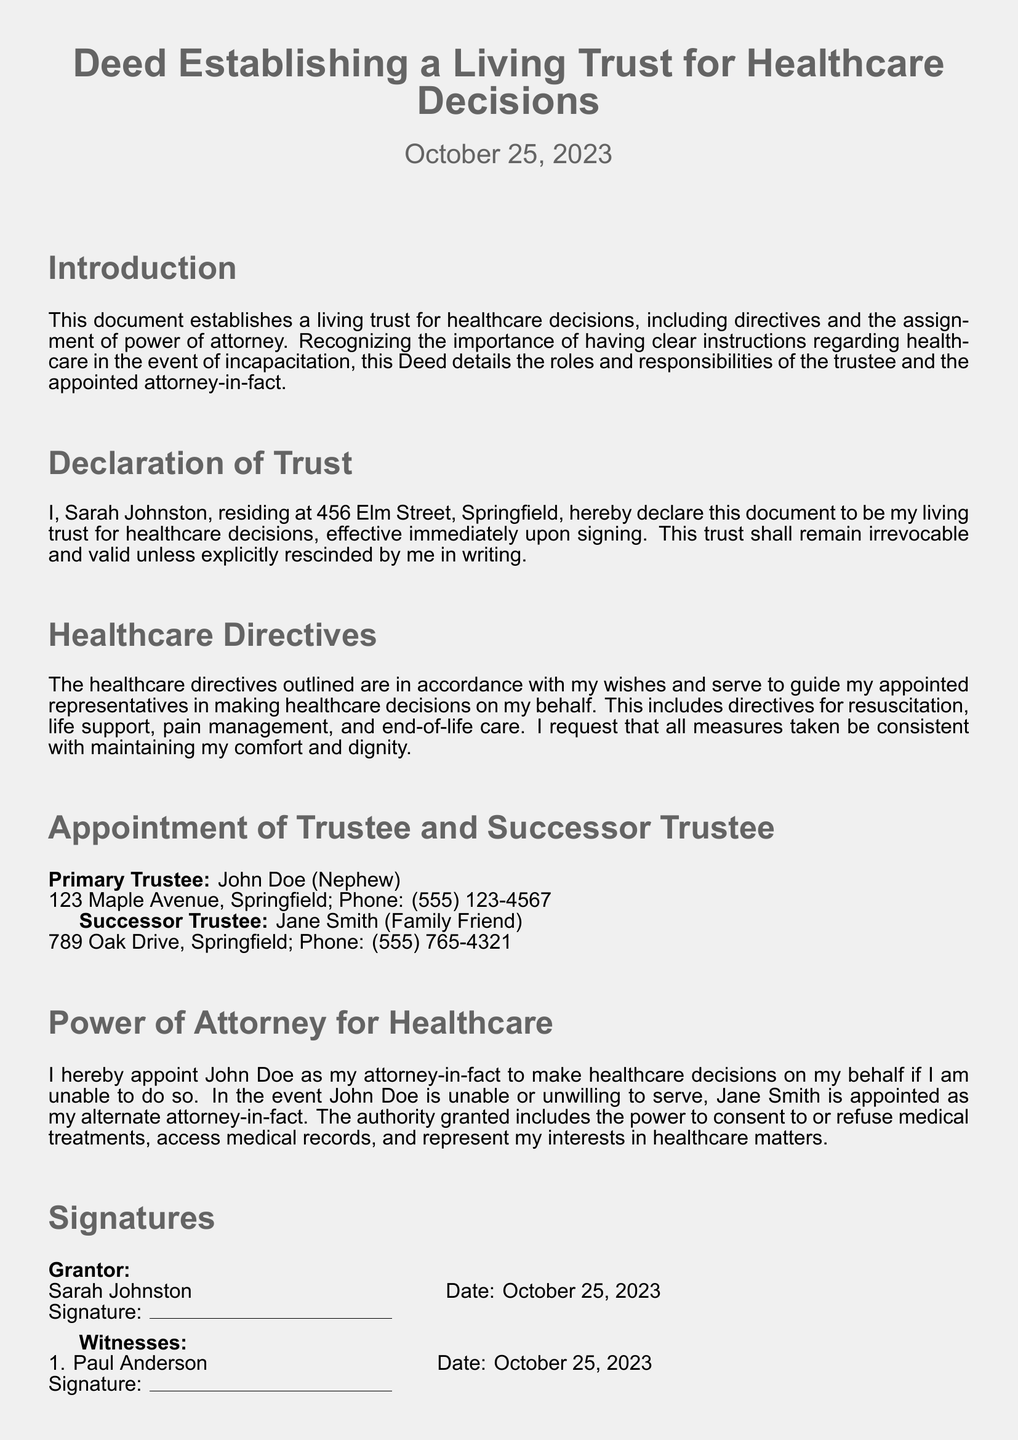What is the date of the document? The date of the document is mentioned at the top, indicating its creation date.
Answer: October 25, 2023 Who is the primary trustee? The primary trustee is specified along with their relationship to the grantor.
Answer: John Doe (Nephew) What is the address of the primary trustee? The address for the primary trustee is provided alongside their name.
Answer: 123 Maple Avenue, Springfield What is the role of John Doe? The role of John Doe is explicitly stated in the section about power of attorney.
Answer: Attorney-in-fact What is the purpose of the document? The introduction section clarifies the intention behind creating this document.
Answer: Establish a living trust for healthcare decisions Who signed as a witness? The document lists two individuals who acted as witnesses and their names are provided.
Answer: Paul Anderson What authority does the attorney-in-fact have? The power granted to the attorney-in-fact includes various healthcare-related decisions.
Answer: Consent to or refuse medical treatments What type of trust is established in this document? The document specifies the kind of trust being established.
Answer: Living trust for healthcare decisions Who is the successor trustee? The successor trustee is noted in the section detailing trustee appointments.
Answer: Jane Smith (Family Friend) 